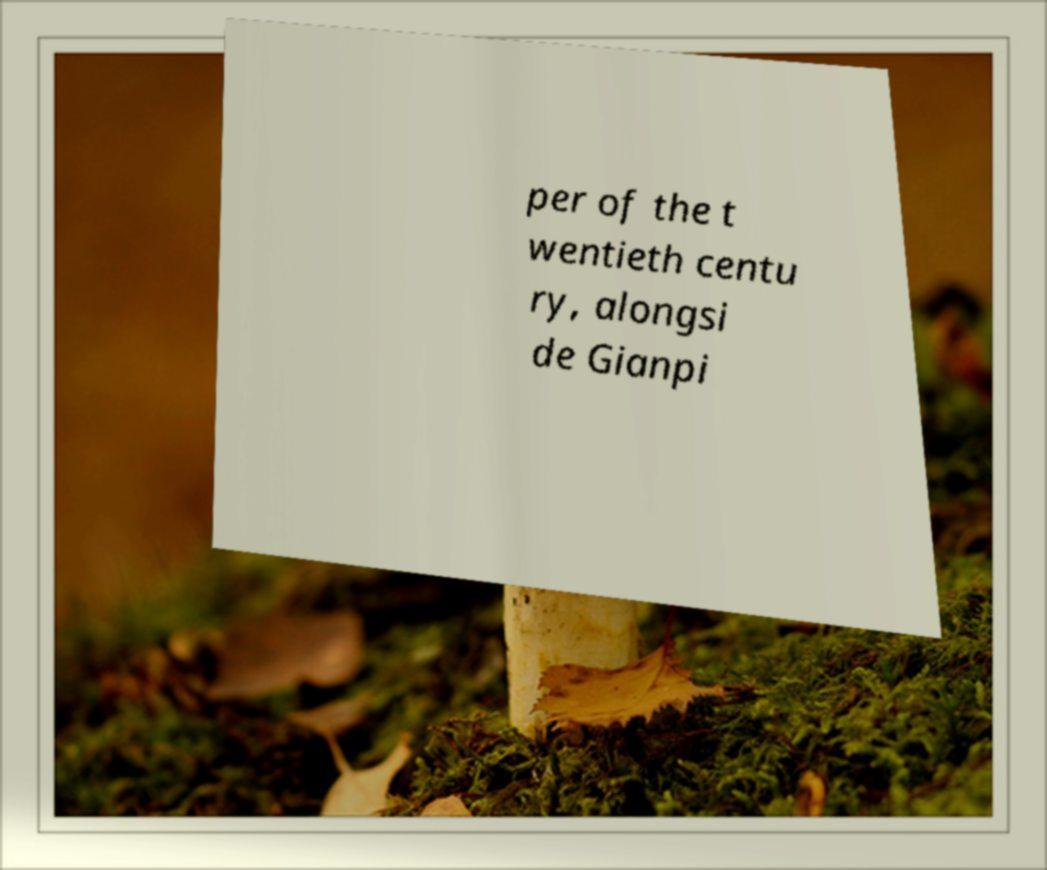For documentation purposes, I need the text within this image transcribed. Could you provide that? per of the t wentieth centu ry, alongsi de Gianpi 